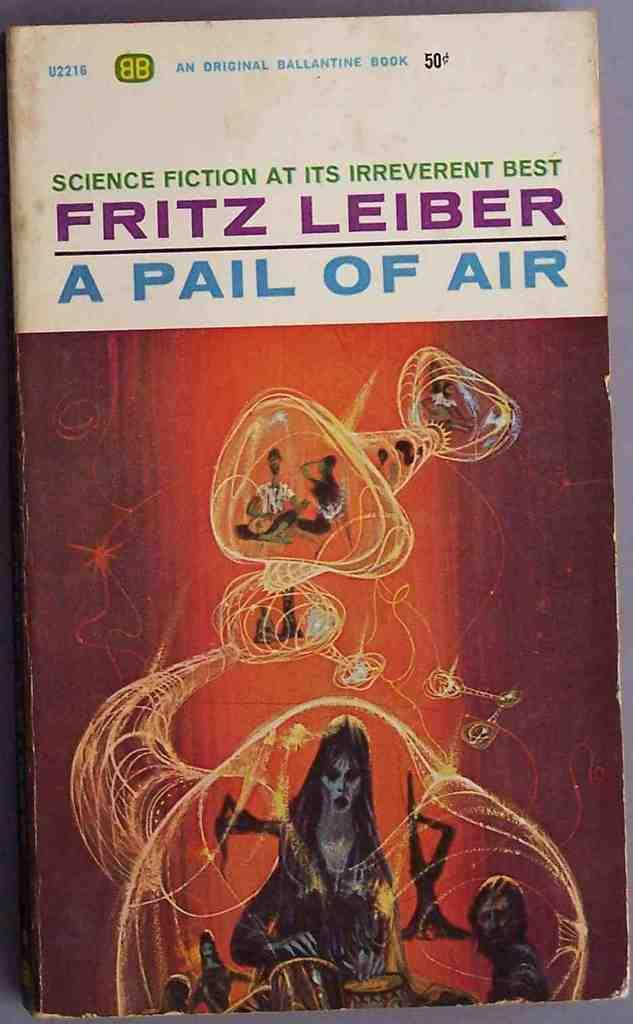<image>
Share a concise interpretation of the image provided. A book cover titled A Pail of Air by Fritz Leiber. 